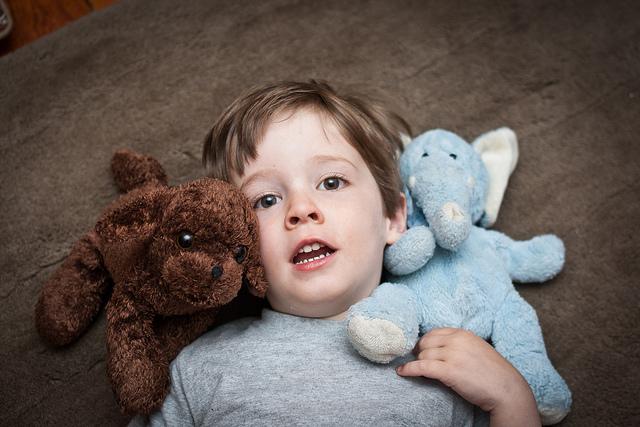How old is this child?
Give a very brief answer. 4. Where is the teddy bear holding the stuffed duck?
Short answer required. Not pictured. What kind of animal is the blue stuffed animal?
Answer briefly. Elephant. Where is the elephant?
Give a very brief answer. On right. 